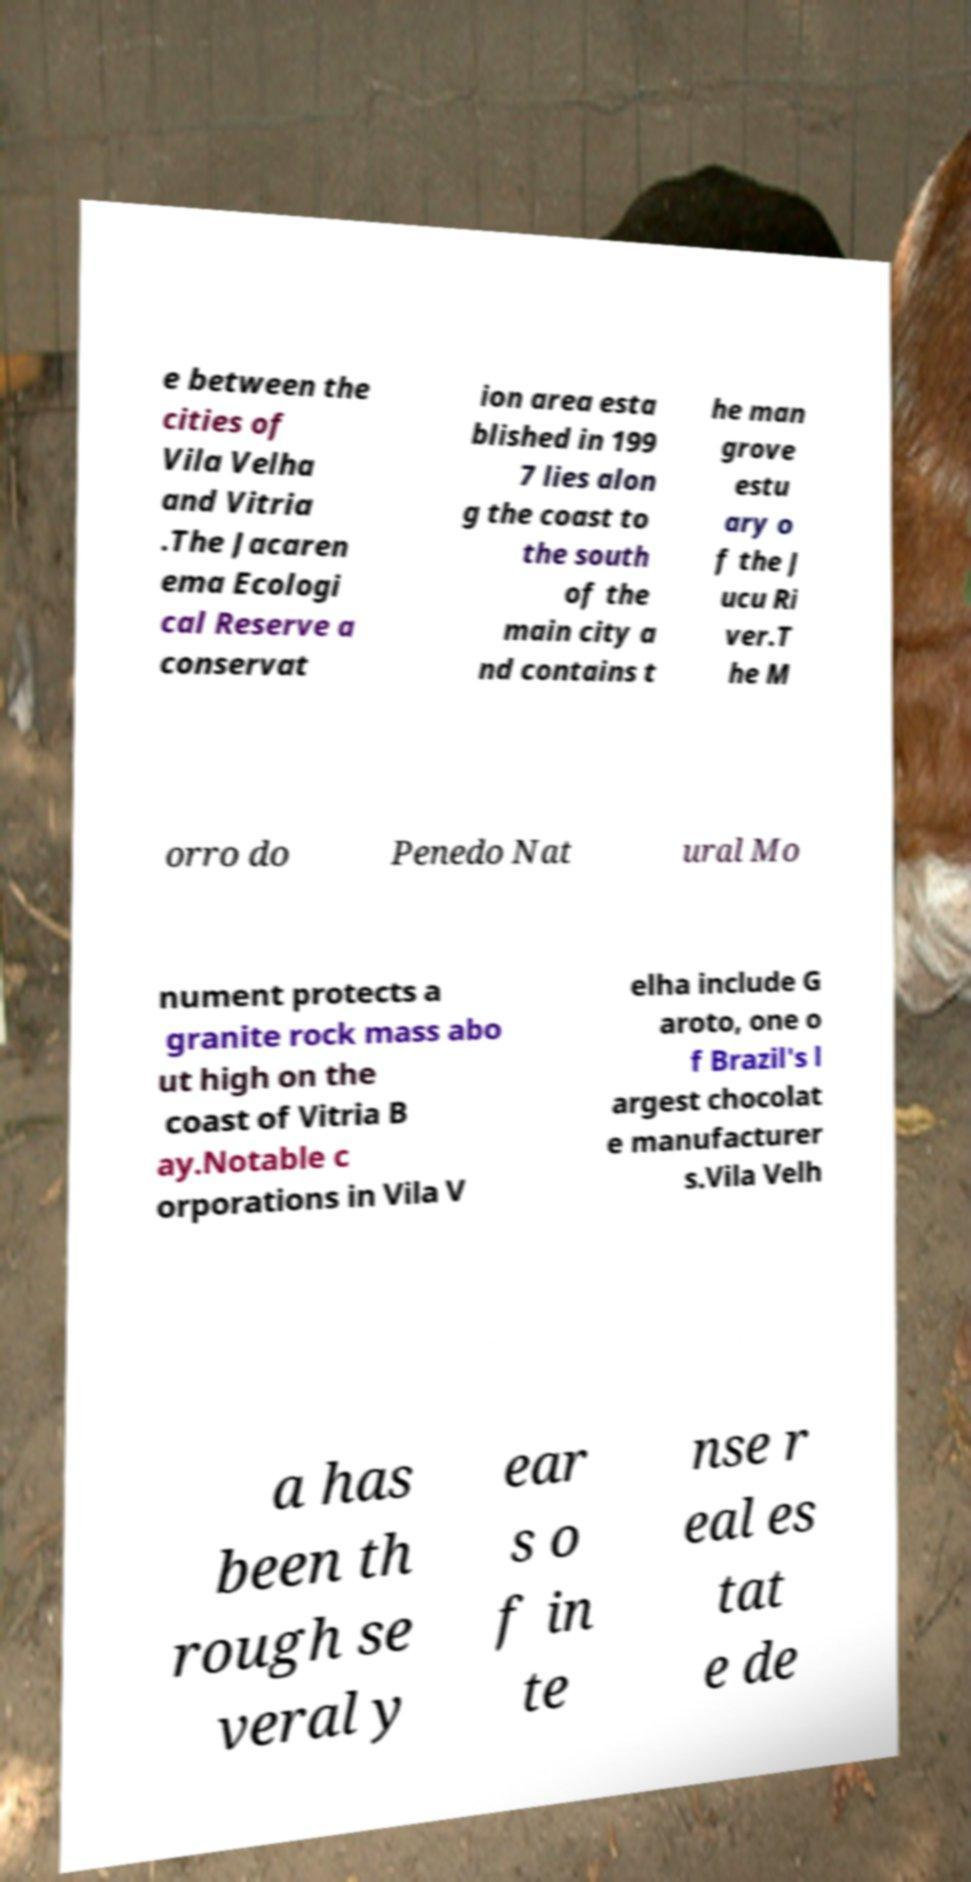I need the written content from this picture converted into text. Can you do that? e between the cities of Vila Velha and Vitria .The Jacaren ema Ecologi cal Reserve a conservat ion area esta blished in 199 7 lies alon g the coast to the south of the main city a nd contains t he man grove estu ary o f the J ucu Ri ver.T he M orro do Penedo Nat ural Mo nument protects a granite rock mass abo ut high on the coast of Vitria B ay.Notable c orporations in Vila V elha include G aroto, one o f Brazil's l argest chocolat e manufacturer s.Vila Velh a has been th rough se veral y ear s o f in te nse r eal es tat e de 